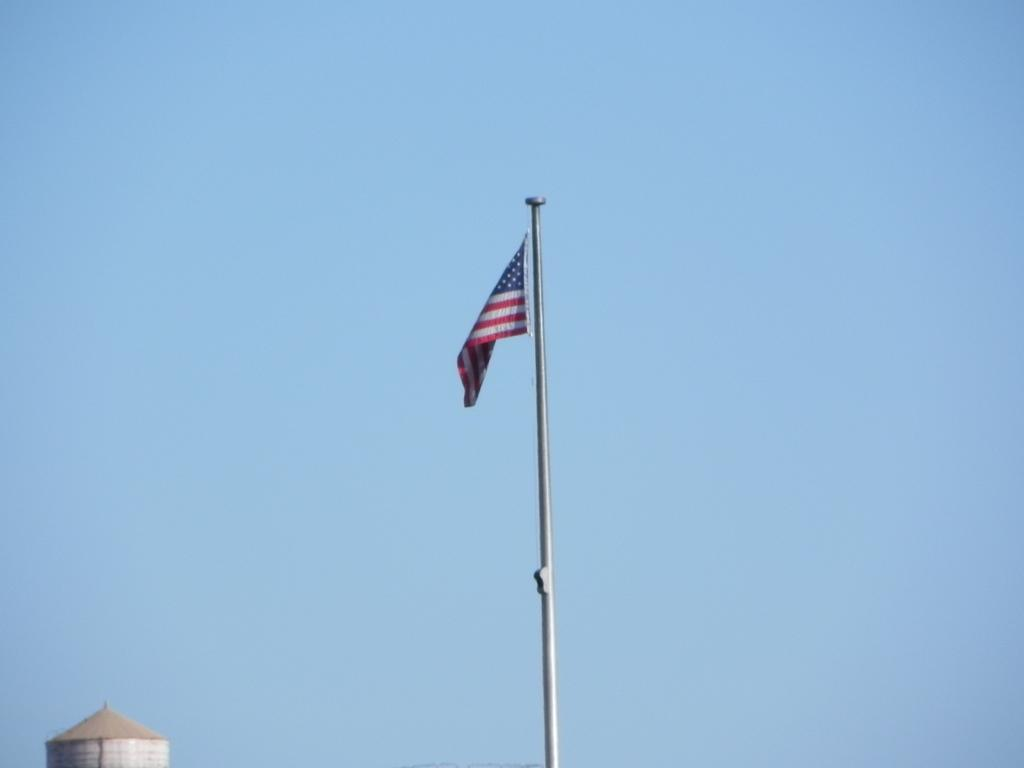What structure is located in the bottom left corner of the image? There is a building in the bottom left corner of the image. What can be seen in the middle of the image? There is a flag in the middle of the image. What is visible at the top of the image? The sky is visible at the top of the image. How many screws are holding the flag in place in the image? There is no information about screws in the image, as it only shows a building, a flag, and the sky. Can you see any jellyfish in the image? There are no jellyfish present in the image; it features a building, a flag, and the sky. 